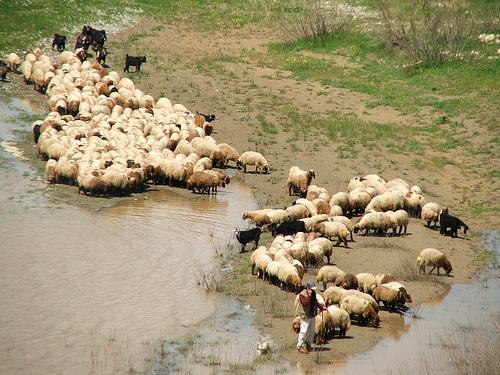How many people are guiding the sheep?
Keep it brief. 1. Are there fewer than twenty sheep?
Keep it brief. No. What animals are all over the rocks?
Concise answer only. Sheep. What color is the water?
Answer briefly. Brown. Are the ship drinking water?
Concise answer only. Yes. 